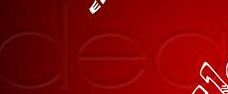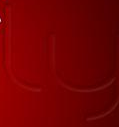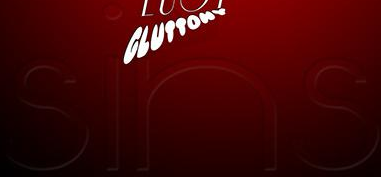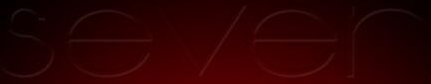What words can you see in these images in sequence, separated by a semicolon? dea; ly; sins; sever 